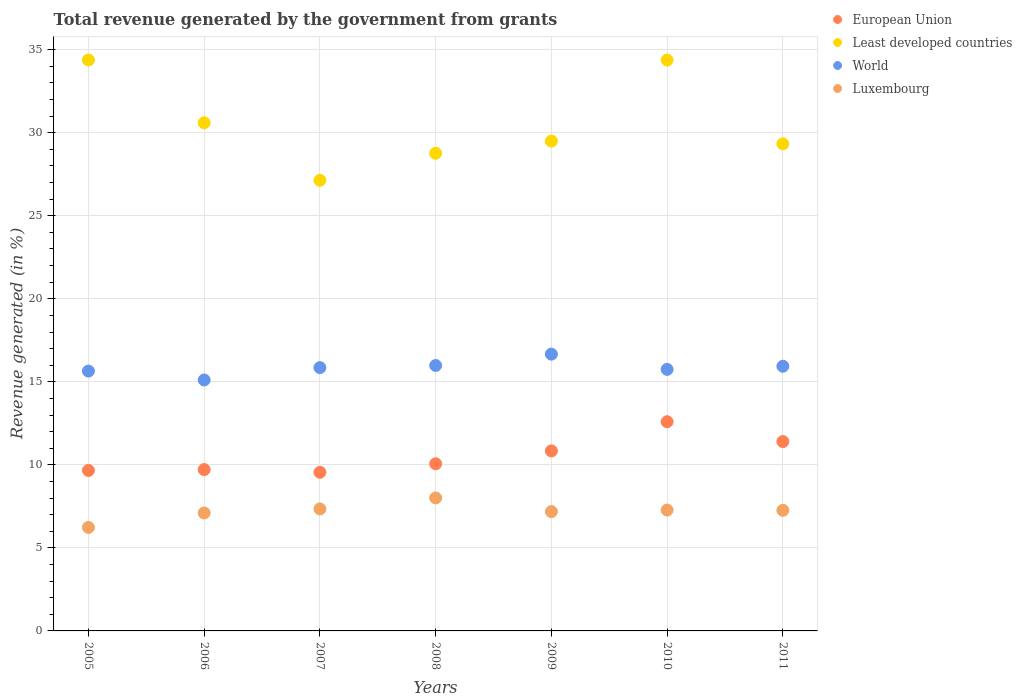How many different coloured dotlines are there?
Provide a succinct answer. 4. What is the total revenue generated in European Union in 2007?
Your answer should be compact. 9.55. Across all years, what is the maximum total revenue generated in Least developed countries?
Your answer should be very brief. 34.38. Across all years, what is the minimum total revenue generated in Least developed countries?
Ensure brevity in your answer.  27.14. In which year was the total revenue generated in European Union minimum?
Provide a succinct answer. 2007. What is the total total revenue generated in European Union in the graph?
Your response must be concise. 73.84. What is the difference between the total revenue generated in European Union in 2006 and that in 2007?
Ensure brevity in your answer.  0.16. What is the difference between the total revenue generated in World in 2011 and the total revenue generated in European Union in 2009?
Ensure brevity in your answer.  5.1. What is the average total revenue generated in World per year?
Keep it short and to the point. 15.85. In the year 2009, what is the difference between the total revenue generated in Least developed countries and total revenue generated in European Union?
Make the answer very short. 18.66. In how many years, is the total revenue generated in Least developed countries greater than 17 %?
Keep it short and to the point. 7. What is the ratio of the total revenue generated in Luxembourg in 2005 to that in 2006?
Provide a succinct answer. 0.88. Is the total revenue generated in World in 2006 less than that in 2008?
Your answer should be compact. Yes. What is the difference between the highest and the second highest total revenue generated in Least developed countries?
Provide a succinct answer. 0.01. What is the difference between the highest and the lowest total revenue generated in Luxembourg?
Provide a short and direct response. 1.78. In how many years, is the total revenue generated in Luxembourg greater than the average total revenue generated in Luxembourg taken over all years?
Offer a terse response. 4. Is it the case that in every year, the sum of the total revenue generated in Least developed countries and total revenue generated in European Union  is greater than the sum of total revenue generated in World and total revenue generated in Luxembourg?
Provide a succinct answer. Yes. Is the total revenue generated in European Union strictly greater than the total revenue generated in Luxembourg over the years?
Offer a terse response. Yes. Is the total revenue generated in World strictly less than the total revenue generated in Least developed countries over the years?
Provide a succinct answer. Yes. How many dotlines are there?
Keep it short and to the point. 4. How many years are there in the graph?
Provide a short and direct response. 7. Are the values on the major ticks of Y-axis written in scientific E-notation?
Provide a short and direct response. No. Does the graph contain any zero values?
Your response must be concise. No. Where does the legend appear in the graph?
Ensure brevity in your answer.  Top right. What is the title of the graph?
Keep it short and to the point. Total revenue generated by the government from grants. Does "Albania" appear as one of the legend labels in the graph?
Offer a very short reply. No. What is the label or title of the X-axis?
Your answer should be compact. Years. What is the label or title of the Y-axis?
Your answer should be compact. Revenue generated (in %). What is the Revenue generated (in %) in European Union in 2005?
Offer a terse response. 9.66. What is the Revenue generated (in %) of Least developed countries in 2005?
Keep it short and to the point. 34.38. What is the Revenue generated (in %) in World in 2005?
Your response must be concise. 15.65. What is the Revenue generated (in %) of Luxembourg in 2005?
Offer a very short reply. 6.23. What is the Revenue generated (in %) of European Union in 2006?
Your answer should be very brief. 9.72. What is the Revenue generated (in %) in Least developed countries in 2006?
Make the answer very short. 30.6. What is the Revenue generated (in %) of World in 2006?
Keep it short and to the point. 15.11. What is the Revenue generated (in %) of Luxembourg in 2006?
Make the answer very short. 7.1. What is the Revenue generated (in %) of European Union in 2007?
Provide a succinct answer. 9.55. What is the Revenue generated (in %) in Least developed countries in 2007?
Keep it short and to the point. 27.14. What is the Revenue generated (in %) of World in 2007?
Give a very brief answer. 15.86. What is the Revenue generated (in %) in Luxembourg in 2007?
Your answer should be compact. 7.35. What is the Revenue generated (in %) of European Union in 2008?
Your response must be concise. 10.07. What is the Revenue generated (in %) in Least developed countries in 2008?
Keep it short and to the point. 28.76. What is the Revenue generated (in %) of World in 2008?
Your answer should be compact. 15.98. What is the Revenue generated (in %) in Luxembourg in 2008?
Offer a terse response. 8.01. What is the Revenue generated (in %) in European Union in 2009?
Offer a terse response. 10.84. What is the Revenue generated (in %) in Least developed countries in 2009?
Offer a terse response. 29.5. What is the Revenue generated (in %) in World in 2009?
Your answer should be compact. 16.67. What is the Revenue generated (in %) of Luxembourg in 2009?
Give a very brief answer. 7.19. What is the Revenue generated (in %) in European Union in 2010?
Offer a very short reply. 12.6. What is the Revenue generated (in %) in Least developed countries in 2010?
Give a very brief answer. 34.38. What is the Revenue generated (in %) in World in 2010?
Give a very brief answer. 15.75. What is the Revenue generated (in %) in Luxembourg in 2010?
Keep it short and to the point. 7.28. What is the Revenue generated (in %) in European Union in 2011?
Your response must be concise. 11.4. What is the Revenue generated (in %) of Least developed countries in 2011?
Make the answer very short. 29.33. What is the Revenue generated (in %) in World in 2011?
Your response must be concise. 15.94. What is the Revenue generated (in %) of Luxembourg in 2011?
Offer a very short reply. 7.26. Across all years, what is the maximum Revenue generated (in %) of European Union?
Ensure brevity in your answer.  12.6. Across all years, what is the maximum Revenue generated (in %) in Least developed countries?
Ensure brevity in your answer.  34.38. Across all years, what is the maximum Revenue generated (in %) in World?
Offer a very short reply. 16.67. Across all years, what is the maximum Revenue generated (in %) of Luxembourg?
Your answer should be compact. 8.01. Across all years, what is the minimum Revenue generated (in %) in European Union?
Offer a very short reply. 9.55. Across all years, what is the minimum Revenue generated (in %) in Least developed countries?
Ensure brevity in your answer.  27.14. Across all years, what is the minimum Revenue generated (in %) in World?
Provide a short and direct response. 15.11. Across all years, what is the minimum Revenue generated (in %) in Luxembourg?
Your answer should be very brief. 6.23. What is the total Revenue generated (in %) in European Union in the graph?
Offer a very short reply. 73.84. What is the total Revenue generated (in %) in Least developed countries in the graph?
Your answer should be very brief. 214.09. What is the total Revenue generated (in %) of World in the graph?
Your answer should be very brief. 110.96. What is the total Revenue generated (in %) in Luxembourg in the graph?
Make the answer very short. 50.42. What is the difference between the Revenue generated (in %) of European Union in 2005 and that in 2006?
Provide a succinct answer. -0.05. What is the difference between the Revenue generated (in %) in Least developed countries in 2005 and that in 2006?
Ensure brevity in your answer.  3.78. What is the difference between the Revenue generated (in %) in World in 2005 and that in 2006?
Provide a short and direct response. 0.54. What is the difference between the Revenue generated (in %) of Luxembourg in 2005 and that in 2006?
Keep it short and to the point. -0.87. What is the difference between the Revenue generated (in %) of European Union in 2005 and that in 2007?
Ensure brevity in your answer.  0.11. What is the difference between the Revenue generated (in %) in Least developed countries in 2005 and that in 2007?
Your answer should be compact. 7.25. What is the difference between the Revenue generated (in %) of World in 2005 and that in 2007?
Provide a short and direct response. -0.21. What is the difference between the Revenue generated (in %) in Luxembourg in 2005 and that in 2007?
Your response must be concise. -1.12. What is the difference between the Revenue generated (in %) of European Union in 2005 and that in 2008?
Give a very brief answer. -0.4. What is the difference between the Revenue generated (in %) of Least developed countries in 2005 and that in 2008?
Make the answer very short. 5.62. What is the difference between the Revenue generated (in %) in World in 2005 and that in 2008?
Offer a very short reply. -0.34. What is the difference between the Revenue generated (in %) in Luxembourg in 2005 and that in 2008?
Your answer should be compact. -1.78. What is the difference between the Revenue generated (in %) in European Union in 2005 and that in 2009?
Give a very brief answer. -1.18. What is the difference between the Revenue generated (in %) of Least developed countries in 2005 and that in 2009?
Provide a short and direct response. 4.89. What is the difference between the Revenue generated (in %) of World in 2005 and that in 2009?
Make the answer very short. -1.02. What is the difference between the Revenue generated (in %) in Luxembourg in 2005 and that in 2009?
Keep it short and to the point. -0.95. What is the difference between the Revenue generated (in %) in European Union in 2005 and that in 2010?
Give a very brief answer. -2.93. What is the difference between the Revenue generated (in %) in Least developed countries in 2005 and that in 2010?
Make the answer very short. 0.01. What is the difference between the Revenue generated (in %) of World in 2005 and that in 2010?
Ensure brevity in your answer.  -0.1. What is the difference between the Revenue generated (in %) in Luxembourg in 2005 and that in 2010?
Make the answer very short. -1.05. What is the difference between the Revenue generated (in %) of European Union in 2005 and that in 2011?
Ensure brevity in your answer.  -1.74. What is the difference between the Revenue generated (in %) of Least developed countries in 2005 and that in 2011?
Your response must be concise. 5.05. What is the difference between the Revenue generated (in %) of World in 2005 and that in 2011?
Provide a succinct answer. -0.29. What is the difference between the Revenue generated (in %) in Luxembourg in 2005 and that in 2011?
Provide a short and direct response. -1.03. What is the difference between the Revenue generated (in %) in European Union in 2006 and that in 2007?
Offer a terse response. 0.16. What is the difference between the Revenue generated (in %) of Least developed countries in 2006 and that in 2007?
Keep it short and to the point. 3.46. What is the difference between the Revenue generated (in %) in World in 2006 and that in 2007?
Provide a short and direct response. -0.74. What is the difference between the Revenue generated (in %) of Luxembourg in 2006 and that in 2007?
Keep it short and to the point. -0.25. What is the difference between the Revenue generated (in %) of European Union in 2006 and that in 2008?
Provide a succinct answer. -0.35. What is the difference between the Revenue generated (in %) in Least developed countries in 2006 and that in 2008?
Keep it short and to the point. 1.83. What is the difference between the Revenue generated (in %) of World in 2006 and that in 2008?
Your answer should be very brief. -0.87. What is the difference between the Revenue generated (in %) of Luxembourg in 2006 and that in 2008?
Offer a very short reply. -0.9. What is the difference between the Revenue generated (in %) in European Union in 2006 and that in 2009?
Provide a short and direct response. -1.12. What is the difference between the Revenue generated (in %) of Least developed countries in 2006 and that in 2009?
Offer a terse response. 1.1. What is the difference between the Revenue generated (in %) in World in 2006 and that in 2009?
Give a very brief answer. -1.56. What is the difference between the Revenue generated (in %) of Luxembourg in 2006 and that in 2009?
Provide a succinct answer. -0.08. What is the difference between the Revenue generated (in %) of European Union in 2006 and that in 2010?
Keep it short and to the point. -2.88. What is the difference between the Revenue generated (in %) of Least developed countries in 2006 and that in 2010?
Your answer should be compact. -3.78. What is the difference between the Revenue generated (in %) of World in 2006 and that in 2010?
Offer a terse response. -0.64. What is the difference between the Revenue generated (in %) of Luxembourg in 2006 and that in 2010?
Ensure brevity in your answer.  -0.18. What is the difference between the Revenue generated (in %) in European Union in 2006 and that in 2011?
Provide a short and direct response. -1.69. What is the difference between the Revenue generated (in %) in Least developed countries in 2006 and that in 2011?
Your answer should be very brief. 1.27. What is the difference between the Revenue generated (in %) in World in 2006 and that in 2011?
Offer a terse response. -0.83. What is the difference between the Revenue generated (in %) in Luxembourg in 2006 and that in 2011?
Your answer should be compact. -0.16. What is the difference between the Revenue generated (in %) in European Union in 2007 and that in 2008?
Provide a short and direct response. -0.51. What is the difference between the Revenue generated (in %) of Least developed countries in 2007 and that in 2008?
Your response must be concise. -1.63. What is the difference between the Revenue generated (in %) of World in 2007 and that in 2008?
Give a very brief answer. -0.13. What is the difference between the Revenue generated (in %) in Luxembourg in 2007 and that in 2008?
Your response must be concise. -0.66. What is the difference between the Revenue generated (in %) in European Union in 2007 and that in 2009?
Make the answer very short. -1.29. What is the difference between the Revenue generated (in %) of Least developed countries in 2007 and that in 2009?
Offer a very short reply. -2.36. What is the difference between the Revenue generated (in %) of World in 2007 and that in 2009?
Provide a succinct answer. -0.81. What is the difference between the Revenue generated (in %) in Luxembourg in 2007 and that in 2009?
Keep it short and to the point. 0.16. What is the difference between the Revenue generated (in %) of European Union in 2007 and that in 2010?
Provide a succinct answer. -3.05. What is the difference between the Revenue generated (in %) of Least developed countries in 2007 and that in 2010?
Offer a very short reply. -7.24. What is the difference between the Revenue generated (in %) of World in 2007 and that in 2010?
Offer a very short reply. 0.11. What is the difference between the Revenue generated (in %) in Luxembourg in 2007 and that in 2010?
Keep it short and to the point. 0.07. What is the difference between the Revenue generated (in %) of European Union in 2007 and that in 2011?
Ensure brevity in your answer.  -1.85. What is the difference between the Revenue generated (in %) in Least developed countries in 2007 and that in 2011?
Ensure brevity in your answer.  -2.19. What is the difference between the Revenue generated (in %) in World in 2007 and that in 2011?
Keep it short and to the point. -0.08. What is the difference between the Revenue generated (in %) in Luxembourg in 2007 and that in 2011?
Your answer should be very brief. 0.09. What is the difference between the Revenue generated (in %) in European Union in 2008 and that in 2009?
Make the answer very short. -0.78. What is the difference between the Revenue generated (in %) of Least developed countries in 2008 and that in 2009?
Offer a terse response. -0.73. What is the difference between the Revenue generated (in %) in World in 2008 and that in 2009?
Your response must be concise. -0.68. What is the difference between the Revenue generated (in %) of Luxembourg in 2008 and that in 2009?
Ensure brevity in your answer.  0.82. What is the difference between the Revenue generated (in %) of European Union in 2008 and that in 2010?
Ensure brevity in your answer.  -2.53. What is the difference between the Revenue generated (in %) in Least developed countries in 2008 and that in 2010?
Ensure brevity in your answer.  -5.61. What is the difference between the Revenue generated (in %) in World in 2008 and that in 2010?
Offer a terse response. 0.23. What is the difference between the Revenue generated (in %) in Luxembourg in 2008 and that in 2010?
Offer a very short reply. 0.73. What is the difference between the Revenue generated (in %) of European Union in 2008 and that in 2011?
Offer a terse response. -1.34. What is the difference between the Revenue generated (in %) of Least developed countries in 2008 and that in 2011?
Offer a terse response. -0.57. What is the difference between the Revenue generated (in %) in World in 2008 and that in 2011?
Give a very brief answer. 0.04. What is the difference between the Revenue generated (in %) in Luxembourg in 2008 and that in 2011?
Your answer should be compact. 0.75. What is the difference between the Revenue generated (in %) of European Union in 2009 and that in 2010?
Provide a succinct answer. -1.76. What is the difference between the Revenue generated (in %) in Least developed countries in 2009 and that in 2010?
Your response must be concise. -4.88. What is the difference between the Revenue generated (in %) in World in 2009 and that in 2010?
Make the answer very short. 0.92. What is the difference between the Revenue generated (in %) in Luxembourg in 2009 and that in 2010?
Ensure brevity in your answer.  -0.09. What is the difference between the Revenue generated (in %) of European Union in 2009 and that in 2011?
Provide a short and direct response. -0.56. What is the difference between the Revenue generated (in %) in Least developed countries in 2009 and that in 2011?
Provide a succinct answer. 0.17. What is the difference between the Revenue generated (in %) of World in 2009 and that in 2011?
Your answer should be compact. 0.73. What is the difference between the Revenue generated (in %) in Luxembourg in 2009 and that in 2011?
Keep it short and to the point. -0.08. What is the difference between the Revenue generated (in %) of European Union in 2010 and that in 2011?
Make the answer very short. 1.19. What is the difference between the Revenue generated (in %) in Least developed countries in 2010 and that in 2011?
Make the answer very short. 5.04. What is the difference between the Revenue generated (in %) of World in 2010 and that in 2011?
Offer a terse response. -0.19. What is the difference between the Revenue generated (in %) in Luxembourg in 2010 and that in 2011?
Provide a succinct answer. 0.02. What is the difference between the Revenue generated (in %) in European Union in 2005 and the Revenue generated (in %) in Least developed countries in 2006?
Your answer should be very brief. -20.94. What is the difference between the Revenue generated (in %) of European Union in 2005 and the Revenue generated (in %) of World in 2006?
Your answer should be compact. -5.45. What is the difference between the Revenue generated (in %) of European Union in 2005 and the Revenue generated (in %) of Luxembourg in 2006?
Offer a very short reply. 2.56. What is the difference between the Revenue generated (in %) in Least developed countries in 2005 and the Revenue generated (in %) in World in 2006?
Your answer should be compact. 19.27. What is the difference between the Revenue generated (in %) in Least developed countries in 2005 and the Revenue generated (in %) in Luxembourg in 2006?
Offer a very short reply. 27.28. What is the difference between the Revenue generated (in %) in World in 2005 and the Revenue generated (in %) in Luxembourg in 2006?
Your answer should be very brief. 8.54. What is the difference between the Revenue generated (in %) in European Union in 2005 and the Revenue generated (in %) in Least developed countries in 2007?
Keep it short and to the point. -17.47. What is the difference between the Revenue generated (in %) in European Union in 2005 and the Revenue generated (in %) in World in 2007?
Offer a terse response. -6.19. What is the difference between the Revenue generated (in %) of European Union in 2005 and the Revenue generated (in %) of Luxembourg in 2007?
Ensure brevity in your answer.  2.31. What is the difference between the Revenue generated (in %) in Least developed countries in 2005 and the Revenue generated (in %) in World in 2007?
Offer a very short reply. 18.53. What is the difference between the Revenue generated (in %) in Least developed countries in 2005 and the Revenue generated (in %) in Luxembourg in 2007?
Provide a succinct answer. 27.03. What is the difference between the Revenue generated (in %) in World in 2005 and the Revenue generated (in %) in Luxembourg in 2007?
Give a very brief answer. 8.3. What is the difference between the Revenue generated (in %) in European Union in 2005 and the Revenue generated (in %) in Least developed countries in 2008?
Offer a terse response. -19.1. What is the difference between the Revenue generated (in %) of European Union in 2005 and the Revenue generated (in %) of World in 2008?
Provide a succinct answer. -6.32. What is the difference between the Revenue generated (in %) of European Union in 2005 and the Revenue generated (in %) of Luxembourg in 2008?
Your answer should be compact. 1.66. What is the difference between the Revenue generated (in %) in Least developed countries in 2005 and the Revenue generated (in %) in World in 2008?
Keep it short and to the point. 18.4. What is the difference between the Revenue generated (in %) in Least developed countries in 2005 and the Revenue generated (in %) in Luxembourg in 2008?
Offer a terse response. 26.38. What is the difference between the Revenue generated (in %) in World in 2005 and the Revenue generated (in %) in Luxembourg in 2008?
Keep it short and to the point. 7.64. What is the difference between the Revenue generated (in %) in European Union in 2005 and the Revenue generated (in %) in Least developed countries in 2009?
Provide a short and direct response. -19.83. What is the difference between the Revenue generated (in %) in European Union in 2005 and the Revenue generated (in %) in World in 2009?
Your answer should be very brief. -7. What is the difference between the Revenue generated (in %) in European Union in 2005 and the Revenue generated (in %) in Luxembourg in 2009?
Your answer should be compact. 2.48. What is the difference between the Revenue generated (in %) of Least developed countries in 2005 and the Revenue generated (in %) of World in 2009?
Your answer should be very brief. 17.72. What is the difference between the Revenue generated (in %) of Least developed countries in 2005 and the Revenue generated (in %) of Luxembourg in 2009?
Offer a very short reply. 27.2. What is the difference between the Revenue generated (in %) of World in 2005 and the Revenue generated (in %) of Luxembourg in 2009?
Make the answer very short. 8.46. What is the difference between the Revenue generated (in %) in European Union in 2005 and the Revenue generated (in %) in Least developed countries in 2010?
Make the answer very short. -24.71. What is the difference between the Revenue generated (in %) in European Union in 2005 and the Revenue generated (in %) in World in 2010?
Give a very brief answer. -6.09. What is the difference between the Revenue generated (in %) of European Union in 2005 and the Revenue generated (in %) of Luxembourg in 2010?
Your response must be concise. 2.38. What is the difference between the Revenue generated (in %) of Least developed countries in 2005 and the Revenue generated (in %) of World in 2010?
Make the answer very short. 18.63. What is the difference between the Revenue generated (in %) in Least developed countries in 2005 and the Revenue generated (in %) in Luxembourg in 2010?
Provide a succinct answer. 27.1. What is the difference between the Revenue generated (in %) of World in 2005 and the Revenue generated (in %) of Luxembourg in 2010?
Offer a very short reply. 8.37. What is the difference between the Revenue generated (in %) of European Union in 2005 and the Revenue generated (in %) of Least developed countries in 2011?
Your answer should be very brief. -19.67. What is the difference between the Revenue generated (in %) in European Union in 2005 and the Revenue generated (in %) in World in 2011?
Offer a very short reply. -6.28. What is the difference between the Revenue generated (in %) in European Union in 2005 and the Revenue generated (in %) in Luxembourg in 2011?
Keep it short and to the point. 2.4. What is the difference between the Revenue generated (in %) of Least developed countries in 2005 and the Revenue generated (in %) of World in 2011?
Your answer should be compact. 18.44. What is the difference between the Revenue generated (in %) in Least developed countries in 2005 and the Revenue generated (in %) in Luxembourg in 2011?
Give a very brief answer. 27.12. What is the difference between the Revenue generated (in %) in World in 2005 and the Revenue generated (in %) in Luxembourg in 2011?
Your response must be concise. 8.38. What is the difference between the Revenue generated (in %) of European Union in 2006 and the Revenue generated (in %) of Least developed countries in 2007?
Offer a terse response. -17.42. What is the difference between the Revenue generated (in %) of European Union in 2006 and the Revenue generated (in %) of World in 2007?
Your answer should be compact. -6.14. What is the difference between the Revenue generated (in %) in European Union in 2006 and the Revenue generated (in %) in Luxembourg in 2007?
Provide a succinct answer. 2.37. What is the difference between the Revenue generated (in %) in Least developed countries in 2006 and the Revenue generated (in %) in World in 2007?
Your answer should be very brief. 14.74. What is the difference between the Revenue generated (in %) of Least developed countries in 2006 and the Revenue generated (in %) of Luxembourg in 2007?
Your response must be concise. 23.25. What is the difference between the Revenue generated (in %) in World in 2006 and the Revenue generated (in %) in Luxembourg in 2007?
Offer a very short reply. 7.76. What is the difference between the Revenue generated (in %) in European Union in 2006 and the Revenue generated (in %) in Least developed countries in 2008?
Your answer should be very brief. -19.05. What is the difference between the Revenue generated (in %) in European Union in 2006 and the Revenue generated (in %) in World in 2008?
Ensure brevity in your answer.  -6.27. What is the difference between the Revenue generated (in %) in European Union in 2006 and the Revenue generated (in %) in Luxembourg in 2008?
Your response must be concise. 1.71. What is the difference between the Revenue generated (in %) in Least developed countries in 2006 and the Revenue generated (in %) in World in 2008?
Give a very brief answer. 14.61. What is the difference between the Revenue generated (in %) of Least developed countries in 2006 and the Revenue generated (in %) of Luxembourg in 2008?
Provide a short and direct response. 22.59. What is the difference between the Revenue generated (in %) in World in 2006 and the Revenue generated (in %) in Luxembourg in 2008?
Provide a short and direct response. 7.1. What is the difference between the Revenue generated (in %) in European Union in 2006 and the Revenue generated (in %) in Least developed countries in 2009?
Offer a very short reply. -19.78. What is the difference between the Revenue generated (in %) in European Union in 2006 and the Revenue generated (in %) in World in 2009?
Offer a terse response. -6.95. What is the difference between the Revenue generated (in %) in European Union in 2006 and the Revenue generated (in %) in Luxembourg in 2009?
Keep it short and to the point. 2.53. What is the difference between the Revenue generated (in %) of Least developed countries in 2006 and the Revenue generated (in %) of World in 2009?
Provide a succinct answer. 13.93. What is the difference between the Revenue generated (in %) of Least developed countries in 2006 and the Revenue generated (in %) of Luxembourg in 2009?
Offer a very short reply. 23.41. What is the difference between the Revenue generated (in %) in World in 2006 and the Revenue generated (in %) in Luxembourg in 2009?
Offer a terse response. 7.93. What is the difference between the Revenue generated (in %) of European Union in 2006 and the Revenue generated (in %) of Least developed countries in 2010?
Your response must be concise. -24.66. What is the difference between the Revenue generated (in %) in European Union in 2006 and the Revenue generated (in %) in World in 2010?
Offer a very short reply. -6.03. What is the difference between the Revenue generated (in %) of European Union in 2006 and the Revenue generated (in %) of Luxembourg in 2010?
Give a very brief answer. 2.44. What is the difference between the Revenue generated (in %) of Least developed countries in 2006 and the Revenue generated (in %) of World in 2010?
Give a very brief answer. 14.85. What is the difference between the Revenue generated (in %) in Least developed countries in 2006 and the Revenue generated (in %) in Luxembourg in 2010?
Provide a succinct answer. 23.32. What is the difference between the Revenue generated (in %) of World in 2006 and the Revenue generated (in %) of Luxembourg in 2010?
Your answer should be compact. 7.83. What is the difference between the Revenue generated (in %) in European Union in 2006 and the Revenue generated (in %) in Least developed countries in 2011?
Your response must be concise. -19.61. What is the difference between the Revenue generated (in %) in European Union in 2006 and the Revenue generated (in %) in World in 2011?
Give a very brief answer. -6.22. What is the difference between the Revenue generated (in %) in European Union in 2006 and the Revenue generated (in %) in Luxembourg in 2011?
Your answer should be very brief. 2.45. What is the difference between the Revenue generated (in %) of Least developed countries in 2006 and the Revenue generated (in %) of World in 2011?
Your answer should be compact. 14.66. What is the difference between the Revenue generated (in %) of Least developed countries in 2006 and the Revenue generated (in %) of Luxembourg in 2011?
Provide a succinct answer. 23.34. What is the difference between the Revenue generated (in %) of World in 2006 and the Revenue generated (in %) of Luxembourg in 2011?
Give a very brief answer. 7.85. What is the difference between the Revenue generated (in %) in European Union in 2007 and the Revenue generated (in %) in Least developed countries in 2008?
Make the answer very short. -19.21. What is the difference between the Revenue generated (in %) in European Union in 2007 and the Revenue generated (in %) in World in 2008?
Make the answer very short. -6.43. What is the difference between the Revenue generated (in %) of European Union in 2007 and the Revenue generated (in %) of Luxembourg in 2008?
Provide a short and direct response. 1.54. What is the difference between the Revenue generated (in %) in Least developed countries in 2007 and the Revenue generated (in %) in World in 2008?
Offer a very short reply. 11.15. What is the difference between the Revenue generated (in %) in Least developed countries in 2007 and the Revenue generated (in %) in Luxembourg in 2008?
Make the answer very short. 19.13. What is the difference between the Revenue generated (in %) of World in 2007 and the Revenue generated (in %) of Luxembourg in 2008?
Your answer should be compact. 7.85. What is the difference between the Revenue generated (in %) in European Union in 2007 and the Revenue generated (in %) in Least developed countries in 2009?
Ensure brevity in your answer.  -19.95. What is the difference between the Revenue generated (in %) of European Union in 2007 and the Revenue generated (in %) of World in 2009?
Make the answer very short. -7.12. What is the difference between the Revenue generated (in %) of European Union in 2007 and the Revenue generated (in %) of Luxembourg in 2009?
Provide a short and direct response. 2.37. What is the difference between the Revenue generated (in %) in Least developed countries in 2007 and the Revenue generated (in %) in World in 2009?
Your response must be concise. 10.47. What is the difference between the Revenue generated (in %) in Least developed countries in 2007 and the Revenue generated (in %) in Luxembourg in 2009?
Offer a terse response. 19.95. What is the difference between the Revenue generated (in %) of World in 2007 and the Revenue generated (in %) of Luxembourg in 2009?
Offer a terse response. 8.67. What is the difference between the Revenue generated (in %) of European Union in 2007 and the Revenue generated (in %) of Least developed countries in 2010?
Ensure brevity in your answer.  -24.82. What is the difference between the Revenue generated (in %) of European Union in 2007 and the Revenue generated (in %) of World in 2010?
Your answer should be compact. -6.2. What is the difference between the Revenue generated (in %) in European Union in 2007 and the Revenue generated (in %) in Luxembourg in 2010?
Provide a succinct answer. 2.27. What is the difference between the Revenue generated (in %) of Least developed countries in 2007 and the Revenue generated (in %) of World in 2010?
Make the answer very short. 11.39. What is the difference between the Revenue generated (in %) of Least developed countries in 2007 and the Revenue generated (in %) of Luxembourg in 2010?
Offer a terse response. 19.86. What is the difference between the Revenue generated (in %) in World in 2007 and the Revenue generated (in %) in Luxembourg in 2010?
Keep it short and to the point. 8.58. What is the difference between the Revenue generated (in %) of European Union in 2007 and the Revenue generated (in %) of Least developed countries in 2011?
Make the answer very short. -19.78. What is the difference between the Revenue generated (in %) in European Union in 2007 and the Revenue generated (in %) in World in 2011?
Make the answer very short. -6.39. What is the difference between the Revenue generated (in %) of European Union in 2007 and the Revenue generated (in %) of Luxembourg in 2011?
Your response must be concise. 2.29. What is the difference between the Revenue generated (in %) in Least developed countries in 2007 and the Revenue generated (in %) in World in 2011?
Offer a terse response. 11.2. What is the difference between the Revenue generated (in %) of Least developed countries in 2007 and the Revenue generated (in %) of Luxembourg in 2011?
Your answer should be very brief. 19.88. What is the difference between the Revenue generated (in %) in World in 2007 and the Revenue generated (in %) in Luxembourg in 2011?
Keep it short and to the point. 8.59. What is the difference between the Revenue generated (in %) in European Union in 2008 and the Revenue generated (in %) in Least developed countries in 2009?
Offer a very short reply. -19.43. What is the difference between the Revenue generated (in %) in European Union in 2008 and the Revenue generated (in %) in World in 2009?
Keep it short and to the point. -6.6. What is the difference between the Revenue generated (in %) in European Union in 2008 and the Revenue generated (in %) in Luxembourg in 2009?
Provide a short and direct response. 2.88. What is the difference between the Revenue generated (in %) of Least developed countries in 2008 and the Revenue generated (in %) of World in 2009?
Provide a short and direct response. 12.1. What is the difference between the Revenue generated (in %) in Least developed countries in 2008 and the Revenue generated (in %) in Luxembourg in 2009?
Ensure brevity in your answer.  21.58. What is the difference between the Revenue generated (in %) in World in 2008 and the Revenue generated (in %) in Luxembourg in 2009?
Your response must be concise. 8.8. What is the difference between the Revenue generated (in %) in European Union in 2008 and the Revenue generated (in %) in Least developed countries in 2010?
Make the answer very short. -24.31. What is the difference between the Revenue generated (in %) in European Union in 2008 and the Revenue generated (in %) in World in 2010?
Give a very brief answer. -5.68. What is the difference between the Revenue generated (in %) of European Union in 2008 and the Revenue generated (in %) of Luxembourg in 2010?
Your answer should be very brief. 2.79. What is the difference between the Revenue generated (in %) in Least developed countries in 2008 and the Revenue generated (in %) in World in 2010?
Provide a succinct answer. 13.02. What is the difference between the Revenue generated (in %) in Least developed countries in 2008 and the Revenue generated (in %) in Luxembourg in 2010?
Your response must be concise. 21.49. What is the difference between the Revenue generated (in %) of World in 2008 and the Revenue generated (in %) of Luxembourg in 2010?
Ensure brevity in your answer.  8.71. What is the difference between the Revenue generated (in %) of European Union in 2008 and the Revenue generated (in %) of Least developed countries in 2011?
Offer a terse response. -19.27. What is the difference between the Revenue generated (in %) of European Union in 2008 and the Revenue generated (in %) of World in 2011?
Give a very brief answer. -5.87. What is the difference between the Revenue generated (in %) in European Union in 2008 and the Revenue generated (in %) in Luxembourg in 2011?
Give a very brief answer. 2.8. What is the difference between the Revenue generated (in %) in Least developed countries in 2008 and the Revenue generated (in %) in World in 2011?
Make the answer very short. 12.82. What is the difference between the Revenue generated (in %) in Least developed countries in 2008 and the Revenue generated (in %) in Luxembourg in 2011?
Offer a terse response. 21.5. What is the difference between the Revenue generated (in %) of World in 2008 and the Revenue generated (in %) of Luxembourg in 2011?
Provide a succinct answer. 8.72. What is the difference between the Revenue generated (in %) of European Union in 2009 and the Revenue generated (in %) of Least developed countries in 2010?
Your answer should be compact. -23.54. What is the difference between the Revenue generated (in %) of European Union in 2009 and the Revenue generated (in %) of World in 2010?
Provide a succinct answer. -4.91. What is the difference between the Revenue generated (in %) of European Union in 2009 and the Revenue generated (in %) of Luxembourg in 2010?
Keep it short and to the point. 3.56. What is the difference between the Revenue generated (in %) in Least developed countries in 2009 and the Revenue generated (in %) in World in 2010?
Provide a succinct answer. 13.75. What is the difference between the Revenue generated (in %) of Least developed countries in 2009 and the Revenue generated (in %) of Luxembourg in 2010?
Provide a short and direct response. 22.22. What is the difference between the Revenue generated (in %) in World in 2009 and the Revenue generated (in %) in Luxembourg in 2010?
Make the answer very short. 9.39. What is the difference between the Revenue generated (in %) in European Union in 2009 and the Revenue generated (in %) in Least developed countries in 2011?
Give a very brief answer. -18.49. What is the difference between the Revenue generated (in %) in European Union in 2009 and the Revenue generated (in %) in World in 2011?
Your answer should be very brief. -5.1. What is the difference between the Revenue generated (in %) of European Union in 2009 and the Revenue generated (in %) of Luxembourg in 2011?
Offer a terse response. 3.58. What is the difference between the Revenue generated (in %) of Least developed countries in 2009 and the Revenue generated (in %) of World in 2011?
Your response must be concise. 13.56. What is the difference between the Revenue generated (in %) in Least developed countries in 2009 and the Revenue generated (in %) in Luxembourg in 2011?
Keep it short and to the point. 22.23. What is the difference between the Revenue generated (in %) in World in 2009 and the Revenue generated (in %) in Luxembourg in 2011?
Offer a terse response. 9.41. What is the difference between the Revenue generated (in %) in European Union in 2010 and the Revenue generated (in %) in Least developed countries in 2011?
Offer a very short reply. -16.73. What is the difference between the Revenue generated (in %) in European Union in 2010 and the Revenue generated (in %) in World in 2011?
Provide a succinct answer. -3.34. What is the difference between the Revenue generated (in %) of European Union in 2010 and the Revenue generated (in %) of Luxembourg in 2011?
Your response must be concise. 5.34. What is the difference between the Revenue generated (in %) of Least developed countries in 2010 and the Revenue generated (in %) of World in 2011?
Ensure brevity in your answer.  18.44. What is the difference between the Revenue generated (in %) in Least developed countries in 2010 and the Revenue generated (in %) in Luxembourg in 2011?
Keep it short and to the point. 27.11. What is the difference between the Revenue generated (in %) of World in 2010 and the Revenue generated (in %) of Luxembourg in 2011?
Your answer should be very brief. 8.49. What is the average Revenue generated (in %) of European Union per year?
Offer a terse response. 10.55. What is the average Revenue generated (in %) in Least developed countries per year?
Offer a very short reply. 30.58. What is the average Revenue generated (in %) in World per year?
Ensure brevity in your answer.  15.85. What is the average Revenue generated (in %) of Luxembourg per year?
Ensure brevity in your answer.  7.2. In the year 2005, what is the difference between the Revenue generated (in %) in European Union and Revenue generated (in %) in Least developed countries?
Make the answer very short. -24.72. In the year 2005, what is the difference between the Revenue generated (in %) in European Union and Revenue generated (in %) in World?
Provide a short and direct response. -5.98. In the year 2005, what is the difference between the Revenue generated (in %) in European Union and Revenue generated (in %) in Luxembourg?
Provide a short and direct response. 3.43. In the year 2005, what is the difference between the Revenue generated (in %) in Least developed countries and Revenue generated (in %) in World?
Your answer should be very brief. 18.74. In the year 2005, what is the difference between the Revenue generated (in %) of Least developed countries and Revenue generated (in %) of Luxembourg?
Make the answer very short. 28.15. In the year 2005, what is the difference between the Revenue generated (in %) in World and Revenue generated (in %) in Luxembourg?
Offer a very short reply. 9.41. In the year 2006, what is the difference between the Revenue generated (in %) of European Union and Revenue generated (in %) of Least developed countries?
Your response must be concise. -20.88. In the year 2006, what is the difference between the Revenue generated (in %) in European Union and Revenue generated (in %) in World?
Your answer should be very brief. -5.4. In the year 2006, what is the difference between the Revenue generated (in %) of European Union and Revenue generated (in %) of Luxembourg?
Offer a terse response. 2.61. In the year 2006, what is the difference between the Revenue generated (in %) of Least developed countries and Revenue generated (in %) of World?
Your answer should be compact. 15.49. In the year 2006, what is the difference between the Revenue generated (in %) in Least developed countries and Revenue generated (in %) in Luxembourg?
Your answer should be very brief. 23.5. In the year 2006, what is the difference between the Revenue generated (in %) in World and Revenue generated (in %) in Luxembourg?
Give a very brief answer. 8.01. In the year 2007, what is the difference between the Revenue generated (in %) of European Union and Revenue generated (in %) of Least developed countries?
Your response must be concise. -17.59. In the year 2007, what is the difference between the Revenue generated (in %) of European Union and Revenue generated (in %) of World?
Provide a succinct answer. -6.3. In the year 2007, what is the difference between the Revenue generated (in %) in European Union and Revenue generated (in %) in Luxembourg?
Offer a terse response. 2.2. In the year 2007, what is the difference between the Revenue generated (in %) in Least developed countries and Revenue generated (in %) in World?
Keep it short and to the point. 11.28. In the year 2007, what is the difference between the Revenue generated (in %) in Least developed countries and Revenue generated (in %) in Luxembourg?
Keep it short and to the point. 19.79. In the year 2007, what is the difference between the Revenue generated (in %) of World and Revenue generated (in %) of Luxembourg?
Provide a short and direct response. 8.51. In the year 2008, what is the difference between the Revenue generated (in %) in European Union and Revenue generated (in %) in Least developed countries?
Provide a succinct answer. -18.7. In the year 2008, what is the difference between the Revenue generated (in %) of European Union and Revenue generated (in %) of World?
Offer a terse response. -5.92. In the year 2008, what is the difference between the Revenue generated (in %) of European Union and Revenue generated (in %) of Luxembourg?
Keep it short and to the point. 2.06. In the year 2008, what is the difference between the Revenue generated (in %) in Least developed countries and Revenue generated (in %) in World?
Make the answer very short. 12.78. In the year 2008, what is the difference between the Revenue generated (in %) of Least developed countries and Revenue generated (in %) of Luxembourg?
Provide a succinct answer. 20.76. In the year 2008, what is the difference between the Revenue generated (in %) in World and Revenue generated (in %) in Luxembourg?
Your response must be concise. 7.98. In the year 2009, what is the difference between the Revenue generated (in %) of European Union and Revenue generated (in %) of Least developed countries?
Keep it short and to the point. -18.66. In the year 2009, what is the difference between the Revenue generated (in %) in European Union and Revenue generated (in %) in World?
Keep it short and to the point. -5.83. In the year 2009, what is the difference between the Revenue generated (in %) in European Union and Revenue generated (in %) in Luxembourg?
Your answer should be very brief. 3.66. In the year 2009, what is the difference between the Revenue generated (in %) in Least developed countries and Revenue generated (in %) in World?
Offer a very short reply. 12.83. In the year 2009, what is the difference between the Revenue generated (in %) in Least developed countries and Revenue generated (in %) in Luxembourg?
Offer a very short reply. 22.31. In the year 2009, what is the difference between the Revenue generated (in %) of World and Revenue generated (in %) of Luxembourg?
Your answer should be compact. 9.48. In the year 2010, what is the difference between the Revenue generated (in %) of European Union and Revenue generated (in %) of Least developed countries?
Give a very brief answer. -21.78. In the year 2010, what is the difference between the Revenue generated (in %) of European Union and Revenue generated (in %) of World?
Make the answer very short. -3.15. In the year 2010, what is the difference between the Revenue generated (in %) of European Union and Revenue generated (in %) of Luxembourg?
Offer a terse response. 5.32. In the year 2010, what is the difference between the Revenue generated (in %) in Least developed countries and Revenue generated (in %) in World?
Your answer should be compact. 18.63. In the year 2010, what is the difference between the Revenue generated (in %) in Least developed countries and Revenue generated (in %) in Luxembourg?
Offer a terse response. 27.1. In the year 2010, what is the difference between the Revenue generated (in %) in World and Revenue generated (in %) in Luxembourg?
Provide a succinct answer. 8.47. In the year 2011, what is the difference between the Revenue generated (in %) of European Union and Revenue generated (in %) of Least developed countries?
Offer a very short reply. -17.93. In the year 2011, what is the difference between the Revenue generated (in %) of European Union and Revenue generated (in %) of World?
Your response must be concise. -4.54. In the year 2011, what is the difference between the Revenue generated (in %) of European Union and Revenue generated (in %) of Luxembourg?
Your answer should be compact. 4.14. In the year 2011, what is the difference between the Revenue generated (in %) of Least developed countries and Revenue generated (in %) of World?
Make the answer very short. 13.39. In the year 2011, what is the difference between the Revenue generated (in %) of Least developed countries and Revenue generated (in %) of Luxembourg?
Ensure brevity in your answer.  22.07. In the year 2011, what is the difference between the Revenue generated (in %) in World and Revenue generated (in %) in Luxembourg?
Your answer should be very brief. 8.68. What is the ratio of the Revenue generated (in %) of Least developed countries in 2005 to that in 2006?
Offer a terse response. 1.12. What is the ratio of the Revenue generated (in %) in World in 2005 to that in 2006?
Keep it short and to the point. 1.04. What is the ratio of the Revenue generated (in %) of Luxembourg in 2005 to that in 2006?
Provide a short and direct response. 0.88. What is the ratio of the Revenue generated (in %) of European Union in 2005 to that in 2007?
Your answer should be compact. 1.01. What is the ratio of the Revenue generated (in %) of Least developed countries in 2005 to that in 2007?
Your response must be concise. 1.27. What is the ratio of the Revenue generated (in %) of World in 2005 to that in 2007?
Give a very brief answer. 0.99. What is the ratio of the Revenue generated (in %) of Luxembourg in 2005 to that in 2007?
Ensure brevity in your answer.  0.85. What is the ratio of the Revenue generated (in %) in European Union in 2005 to that in 2008?
Offer a very short reply. 0.96. What is the ratio of the Revenue generated (in %) in Least developed countries in 2005 to that in 2008?
Offer a terse response. 1.2. What is the ratio of the Revenue generated (in %) of World in 2005 to that in 2008?
Keep it short and to the point. 0.98. What is the ratio of the Revenue generated (in %) in Luxembourg in 2005 to that in 2008?
Provide a short and direct response. 0.78. What is the ratio of the Revenue generated (in %) of European Union in 2005 to that in 2009?
Offer a terse response. 0.89. What is the ratio of the Revenue generated (in %) in Least developed countries in 2005 to that in 2009?
Offer a very short reply. 1.17. What is the ratio of the Revenue generated (in %) in World in 2005 to that in 2009?
Provide a succinct answer. 0.94. What is the ratio of the Revenue generated (in %) in Luxembourg in 2005 to that in 2009?
Make the answer very short. 0.87. What is the ratio of the Revenue generated (in %) of European Union in 2005 to that in 2010?
Make the answer very short. 0.77. What is the ratio of the Revenue generated (in %) in Least developed countries in 2005 to that in 2010?
Your response must be concise. 1. What is the ratio of the Revenue generated (in %) of Luxembourg in 2005 to that in 2010?
Keep it short and to the point. 0.86. What is the ratio of the Revenue generated (in %) in European Union in 2005 to that in 2011?
Provide a succinct answer. 0.85. What is the ratio of the Revenue generated (in %) of Least developed countries in 2005 to that in 2011?
Your answer should be compact. 1.17. What is the ratio of the Revenue generated (in %) in World in 2005 to that in 2011?
Offer a very short reply. 0.98. What is the ratio of the Revenue generated (in %) in Luxembourg in 2005 to that in 2011?
Give a very brief answer. 0.86. What is the ratio of the Revenue generated (in %) in European Union in 2006 to that in 2007?
Keep it short and to the point. 1.02. What is the ratio of the Revenue generated (in %) of Least developed countries in 2006 to that in 2007?
Make the answer very short. 1.13. What is the ratio of the Revenue generated (in %) of World in 2006 to that in 2007?
Ensure brevity in your answer.  0.95. What is the ratio of the Revenue generated (in %) of Luxembourg in 2006 to that in 2007?
Your response must be concise. 0.97. What is the ratio of the Revenue generated (in %) of European Union in 2006 to that in 2008?
Offer a terse response. 0.97. What is the ratio of the Revenue generated (in %) of Least developed countries in 2006 to that in 2008?
Offer a terse response. 1.06. What is the ratio of the Revenue generated (in %) in World in 2006 to that in 2008?
Offer a very short reply. 0.95. What is the ratio of the Revenue generated (in %) in Luxembourg in 2006 to that in 2008?
Keep it short and to the point. 0.89. What is the ratio of the Revenue generated (in %) in European Union in 2006 to that in 2009?
Offer a very short reply. 0.9. What is the ratio of the Revenue generated (in %) of Least developed countries in 2006 to that in 2009?
Your response must be concise. 1.04. What is the ratio of the Revenue generated (in %) of World in 2006 to that in 2009?
Your answer should be compact. 0.91. What is the ratio of the Revenue generated (in %) of Luxembourg in 2006 to that in 2009?
Your answer should be compact. 0.99. What is the ratio of the Revenue generated (in %) of European Union in 2006 to that in 2010?
Offer a terse response. 0.77. What is the ratio of the Revenue generated (in %) in Least developed countries in 2006 to that in 2010?
Your answer should be compact. 0.89. What is the ratio of the Revenue generated (in %) in World in 2006 to that in 2010?
Your answer should be very brief. 0.96. What is the ratio of the Revenue generated (in %) of Luxembourg in 2006 to that in 2010?
Your answer should be compact. 0.98. What is the ratio of the Revenue generated (in %) of European Union in 2006 to that in 2011?
Offer a terse response. 0.85. What is the ratio of the Revenue generated (in %) in Least developed countries in 2006 to that in 2011?
Offer a very short reply. 1.04. What is the ratio of the Revenue generated (in %) of World in 2006 to that in 2011?
Provide a succinct answer. 0.95. What is the ratio of the Revenue generated (in %) in Luxembourg in 2006 to that in 2011?
Your answer should be very brief. 0.98. What is the ratio of the Revenue generated (in %) in European Union in 2007 to that in 2008?
Your answer should be compact. 0.95. What is the ratio of the Revenue generated (in %) in Least developed countries in 2007 to that in 2008?
Your answer should be very brief. 0.94. What is the ratio of the Revenue generated (in %) of World in 2007 to that in 2008?
Your answer should be very brief. 0.99. What is the ratio of the Revenue generated (in %) in Luxembourg in 2007 to that in 2008?
Your response must be concise. 0.92. What is the ratio of the Revenue generated (in %) of European Union in 2007 to that in 2009?
Offer a terse response. 0.88. What is the ratio of the Revenue generated (in %) in World in 2007 to that in 2009?
Offer a very short reply. 0.95. What is the ratio of the Revenue generated (in %) in Luxembourg in 2007 to that in 2009?
Give a very brief answer. 1.02. What is the ratio of the Revenue generated (in %) in European Union in 2007 to that in 2010?
Offer a terse response. 0.76. What is the ratio of the Revenue generated (in %) in Least developed countries in 2007 to that in 2010?
Offer a very short reply. 0.79. What is the ratio of the Revenue generated (in %) in World in 2007 to that in 2010?
Provide a succinct answer. 1.01. What is the ratio of the Revenue generated (in %) in Luxembourg in 2007 to that in 2010?
Offer a terse response. 1.01. What is the ratio of the Revenue generated (in %) of European Union in 2007 to that in 2011?
Offer a terse response. 0.84. What is the ratio of the Revenue generated (in %) in Least developed countries in 2007 to that in 2011?
Keep it short and to the point. 0.93. What is the ratio of the Revenue generated (in %) in Luxembourg in 2007 to that in 2011?
Make the answer very short. 1.01. What is the ratio of the Revenue generated (in %) in European Union in 2008 to that in 2009?
Your answer should be compact. 0.93. What is the ratio of the Revenue generated (in %) in Least developed countries in 2008 to that in 2009?
Offer a very short reply. 0.98. What is the ratio of the Revenue generated (in %) of World in 2008 to that in 2009?
Make the answer very short. 0.96. What is the ratio of the Revenue generated (in %) of Luxembourg in 2008 to that in 2009?
Provide a short and direct response. 1.11. What is the ratio of the Revenue generated (in %) in European Union in 2008 to that in 2010?
Your answer should be compact. 0.8. What is the ratio of the Revenue generated (in %) in Least developed countries in 2008 to that in 2010?
Keep it short and to the point. 0.84. What is the ratio of the Revenue generated (in %) in World in 2008 to that in 2010?
Your answer should be compact. 1.01. What is the ratio of the Revenue generated (in %) in Luxembourg in 2008 to that in 2010?
Make the answer very short. 1.1. What is the ratio of the Revenue generated (in %) in European Union in 2008 to that in 2011?
Offer a very short reply. 0.88. What is the ratio of the Revenue generated (in %) of Least developed countries in 2008 to that in 2011?
Make the answer very short. 0.98. What is the ratio of the Revenue generated (in %) in Luxembourg in 2008 to that in 2011?
Your answer should be very brief. 1.1. What is the ratio of the Revenue generated (in %) of European Union in 2009 to that in 2010?
Offer a terse response. 0.86. What is the ratio of the Revenue generated (in %) of Least developed countries in 2009 to that in 2010?
Your response must be concise. 0.86. What is the ratio of the Revenue generated (in %) of World in 2009 to that in 2010?
Offer a terse response. 1.06. What is the ratio of the Revenue generated (in %) in Luxembourg in 2009 to that in 2010?
Keep it short and to the point. 0.99. What is the ratio of the Revenue generated (in %) in European Union in 2009 to that in 2011?
Give a very brief answer. 0.95. What is the ratio of the Revenue generated (in %) of Least developed countries in 2009 to that in 2011?
Keep it short and to the point. 1.01. What is the ratio of the Revenue generated (in %) in World in 2009 to that in 2011?
Your answer should be very brief. 1.05. What is the ratio of the Revenue generated (in %) in Luxembourg in 2009 to that in 2011?
Your response must be concise. 0.99. What is the ratio of the Revenue generated (in %) of European Union in 2010 to that in 2011?
Your answer should be very brief. 1.1. What is the ratio of the Revenue generated (in %) of Least developed countries in 2010 to that in 2011?
Ensure brevity in your answer.  1.17. What is the ratio of the Revenue generated (in %) of World in 2010 to that in 2011?
Offer a very short reply. 0.99. What is the ratio of the Revenue generated (in %) of Luxembourg in 2010 to that in 2011?
Provide a succinct answer. 1. What is the difference between the highest and the second highest Revenue generated (in %) in European Union?
Provide a succinct answer. 1.19. What is the difference between the highest and the second highest Revenue generated (in %) of Least developed countries?
Provide a short and direct response. 0.01. What is the difference between the highest and the second highest Revenue generated (in %) of World?
Your response must be concise. 0.68. What is the difference between the highest and the second highest Revenue generated (in %) of Luxembourg?
Your answer should be compact. 0.66. What is the difference between the highest and the lowest Revenue generated (in %) in European Union?
Offer a very short reply. 3.05. What is the difference between the highest and the lowest Revenue generated (in %) in Least developed countries?
Your answer should be compact. 7.25. What is the difference between the highest and the lowest Revenue generated (in %) of World?
Offer a terse response. 1.56. What is the difference between the highest and the lowest Revenue generated (in %) of Luxembourg?
Give a very brief answer. 1.78. 